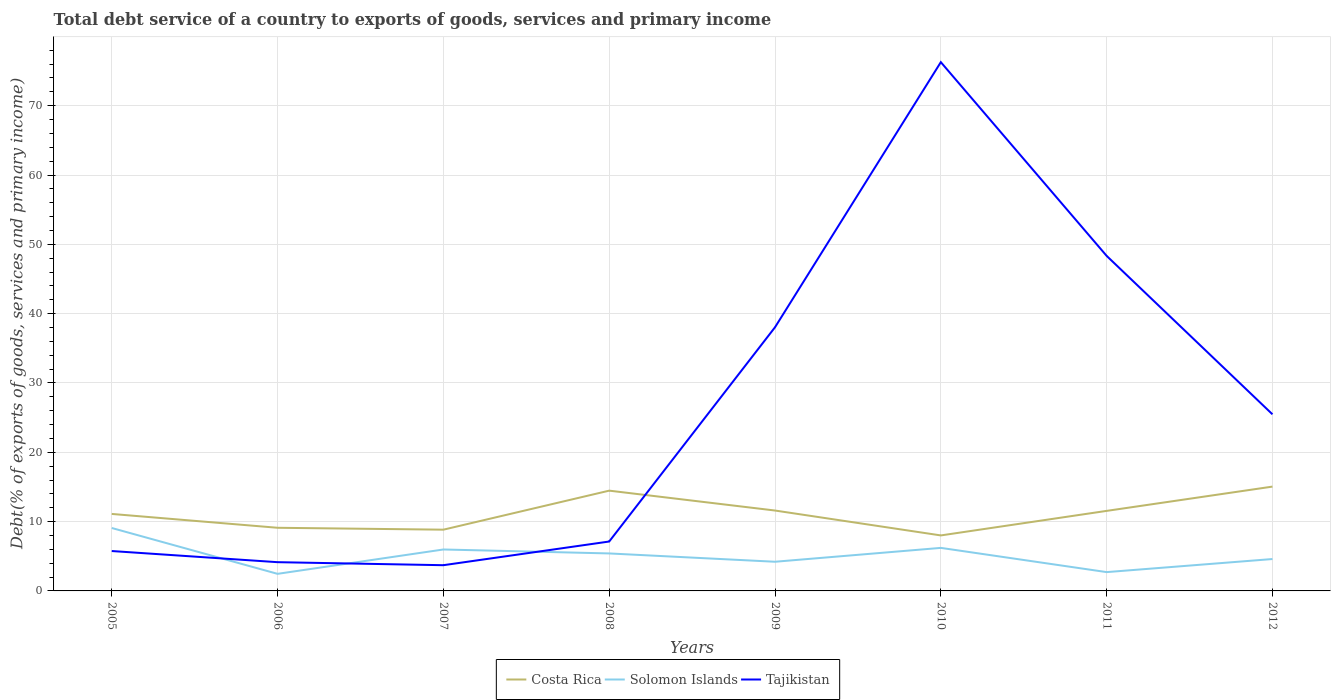How many different coloured lines are there?
Provide a short and direct response. 3. Does the line corresponding to Costa Rica intersect with the line corresponding to Solomon Islands?
Offer a terse response. No. Across all years, what is the maximum total debt service in Costa Rica?
Provide a succinct answer. 8.01. In which year was the total debt service in Solomon Islands maximum?
Your answer should be compact. 2006. What is the total total debt service in Costa Rica in the graph?
Offer a terse response. 2.87. What is the difference between the highest and the second highest total debt service in Solomon Islands?
Your answer should be very brief. 6.61. Are the values on the major ticks of Y-axis written in scientific E-notation?
Provide a short and direct response. No. Does the graph contain any zero values?
Provide a short and direct response. No. Does the graph contain grids?
Keep it short and to the point. Yes. Where does the legend appear in the graph?
Ensure brevity in your answer.  Bottom center. How many legend labels are there?
Provide a short and direct response. 3. What is the title of the graph?
Give a very brief answer. Total debt service of a country to exports of goods, services and primary income. Does "Antigua and Barbuda" appear as one of the legend labels in the graph?
Provide a short and direct response. No. What is the label or title of the X-axis?
Your answer should be compact. Years. What is the label or title of the Y-axis?
Your response must be concise. Debt(% of exports of goods, services and primary income). What is the Debt(% of exports of goods, services and primary income) in Costa Rica in 2005?
Give a very brief answer. 11.11. What is the Debt(% of exports of goods, services and primary income) in Solomon Islands in 2005?
Your answer should be very brief. 9.08. What is the Debt(% of exports of goods, services and primary income) in Tajikistan in 2005?
Your response must be concise. 5.75. What is the Debt(% of exports of goods, services and primary income) in Costa Rica in 2006?
Offer a very short reply. 9.11. What is the Debt(% of exports of goods, services and primary income) in Solomon Islands in 2006?
Offer a very short reply. 2.46. What is the Debt(% of exports of goods, services and primary income) of Tajikistan in 2006?
Make the answer very short. 4.15. What is the Debt(% of exports of goods, services and primary income) of Costa Rica in 2007?
Provide a short and direct response. 8.84. What is the Debt(% of exports of goods, services and primary income) of Solomon Islands in 2007?
Provide a short and direct response. 5.98. What is the Debt(% of exports of goods, services and primary income) in Tajikistan in 2007?
Provide a succinct answer. 3.71. What is the Debt(% of exports of goods, services and primary income) of Costa Rica in 2008?
Offer a very short reply. 14.46. What is the Debt(% of exports of goods, services and primary income) in Solomon Islands in 2008?
Keep it short and to the point. 5.41. What is the Debt(% of exports of goods, services and primary income) in Tajikistan in 2008?
Offer a very short reply. 7.13. What is the Debt(% of exports of goods, services and primary income) in Costa Rica in 2009?
Provide a succinct answer. 11.6. What is the Debt(% of exports of goods, services and primary income) in Solomon Islands in 2009?
Offer a very short reply. 4.21. What is the Debt(% of exports of goods, services and primary income) of Tajikistan in 2009?
Make the answer very short. 38.04. What is the Debt(% of exports of goods, services and primary income) of Costa Rica in 2010?
Make the answer very short. 8.01. What is the Debt(% of exports of goods, services and primary income) in Solomon Islands in 2010?
Your answer should be compact. 6.21. What is the Debt(% of exports of goods, services and primary income) in Tajikistan in 2010?
Offer a very short reply. 76.28. What is the Debt(% of exports of goods, services and primary income) of Costa Rica in 2011?
Your response must be concise. 11.55. What is the Debt(% of exports of goods, services and primary income) in Solomon Islands in 2011?
Your answer should be very brief. 2.71. What is the Debt(% of exports of goods, services and primary income) in Tajikistan in 2011?
Offer a terse response. 48.33. What is the Debt(% of exports of goods, services and primary income) of Costa Rica in 2012?
Make the answer very short. 15.05. What is the Debt(% of exports of goods, services and primary income) of Solomon Islands in 2012?
Offer a very short reply. 4.6. What is the Debt(% of exports of goods, services and primary income) in Tajikistan in 2012?
Keep it short and to the point. 25.48. Across all years, what is the maximum Debt(% of exports of goods, services and primary income) of Costa Rica?
Ensure brevity in your answer.  15.05. Across all years, what is the maximum Debt(% of exports of goods, services and primary income) in Solomon Islands?
Provide a short and direct response. 9.08. Across all years, what is the maximum Debt(% of exports of goods, services and primary income) of Tajikistan?
Give a very brief answer. 76.28. Across all years, what is the minimum Debt(% of exports of goods, services and primary income) of Costa Rica?
Your answer should be compact. 8.01. Across all years, what is the minimum Debt(% of exports of goods, services and primary income) in Solomon Islands?
Offer a terse response. 2.46. Across all years, what is the minimum Debt(% of exports of goods, services and primary income) in Tajikistan?
Provide a short and direct response. 3.71. What is the total Debt(% of exports of goods, services and primary income) of Costa Rica in the graph?
Provide a short and direct response. 89.72. What is the total Debt(% of exports of goods, services and primary income) in Solomon Islands in the graph?
Your answer should be compact. 40.66. What is the total Debt(% of exports of goods, services and primary income) of Tajikistan in the graph?
Keep it short and to the point. 208.86. What is the difference between the Debt(% of exports of goods, services and primary income) in Costa Rica in 2005 and that in 2006?
Offer a very short reply. 2. What is the difference between the Debt(% of exports of goods, services and primary income) of Solomon Islands in 2005 and that in 2006?
Provide a succinct answer. 6.61. What is the difference between the Debt(% of exports of goods, services and primary income) in Tajikistan in 2005 and that in 2006?
Offer a terse response. 1.61. What is the difference between the Debt(% of exports of goods, services and primary income) in Costa Rica in 2005 and that in 2007?
Your answer should be very brief. 2.27. What is the difference between the Debt(% of exports of goods, services and primary income) in Solomon Islands in 2005 and that in 2007?
Your answer should be very brief. 3.1. What is the difference between the Debt(% of exports of goods, services and primary income) in Tajikistan in 2005 and that in 2007?
Your answer should be very brief. 2.04. What is the difference between the Debt(% of exports of goods, services and primary income) in Costa Rica in 2005 and that in 2008?
Provide a succinct answer. -3.36. What is the difference between the Debt(% of exports of goods, services and primary income) of Solomon Islands in 2005 and that in 2008?
Offer a very short reply. 3.67. What is the difference between the Debt(% of exports of goods, services and primary income) in Tajikistan in 2005 and that in 2008?
Make the answer very short. -1.37. What is the difference between the Debt(% of exports of goods, services and primary income) of Costa Rica in 2005 and that in 2009?
Make the answer very short. -0.49. What is the difference between the Debt(% of exports of goods, services and primary income) of Solomon Islands in 2005 and that in 2009?
Your answer should be compact. 4.87. What is the difference between the Debt(% of exports of goods, services and primary income) in Tajikistan in 2005 and that in 2009?
Your answer should be very brief. -32.28. What is the difference between the Debt(% of exports of goods, services and primary income) of Costa Rica in 2005 and that in 2010?
Make the answer very short. 3.1. What is the difference between the Debt(% of exports of goods, services and primary income) in Solomon Islands in 2005 and that in 2010?
Provide a short and direct response. 2.87. What is the difference between the Debt(% of exports of goods, services and primary income) in Tajikistan in 2005 and that in 2010?
Your answer should be very brief. -70.52. What is the difference between the Debt(% of exports of goods, services and primary income) in Costa Rica in 2005 and that in 2011?
Give a very brief answer. -0.44. What is the difference between the Debt(% of exports of goods, services and primary income) in Solomon Islands in 2005 and that in 2011?
Keep it short and to the point. 6.36. What is the difference between the Debt(% of exports of goods, services and primary income) in Tajikistan in 2005 and that in 2011?
Provide a short and direct response. -42.58. What is the difference between the Debt(% of exports of goods, services and primary income) of Costa Rica in 2005 and that in 2012?
Offer a terse response. -3.94. What is the difference between the Debt(% of exports of goods, services and primary income) in Solomon Islands in 2005 and that in 2012?
Give a very brief answer. 4.48. What is the difference between the Debt(% of exports of goods, services and primary income) in Tajikistan in 2005 and that in 2012?
Give a very brief answer. -19.72. What is the difference between the Debt(% of exports of goods, services and primary income) of Costa Rica in 2006 and that in 2007?
Make the answer very short. 0.27. What is the difference between the Debt(% of exports of goods, services and primary income) of Solomon Islands in 2006 and that in 2007?
Give a very brief answer. -3.51. What is the difference between the Debt(% of exports of goods, services and primary income) of Tajikistan in 2006 and that in 2007?
Offer a terse response. 0.44. What is the difference between the Debt(% of exports of goods, services and primary income) in Costa Rica in 2006 and that in 2008?
Offer a very short reply. -5.35. What is the difference between the Debt(% of exports of goods, services and primary income) of Solomon Islands in 2006 and that in 2008?
Offer a terse response. -2.94. What is the difference between the Debt(% of exports of goods, services and primary income) in Tajikistan in 2006 and that in 2008?
Your answer should be compact. -2.98. What is the difference between the Debt(% of exports of goods, services and primary income) of Costa Rica in 2006 and that in 2009?
Offer a very short reply. -2.49. What is the difference between the Debt(% of exports of goods, services and primary income) of Solomon Islands in 2006 and that in 2009?
Ensure brevity in your answer.  -1.74. What is the difference between the Debt(% of exports of goods, services and primary income) of Tajikistan in 2006 and that in 2009?
Ensure brevity in your answer.  -33.89. What is the difference between the Debt(% of exports of goods, services and primary income) of Costa Rica in 2006 and that in 2010?
Give a very brief answer. 1.1. What is the difference between the Debt(% of exports of goods, services and primary income) of Solomon Islands in 2006 and that in 2010?
Provide a short and direct response. -3.74. What is the difference between the Debt(% of exports of goods, services and primary income) in Tajikistan in 2006 and that in 2010?
Provide a short and direct response. -72.13. What is the difference between the Debt(% of exports of goods, services and primary income) of Costa Rica in 2006 and that in 2011?
Your answer should be compact. -2.44. What is the difference between the Debt(% of exports of goods, services and primary income) in Solomon Islands in 2006 and that in 2011?
Give a very brief answer. -0.25. What is the difference between the Debt(% of exports of goods, services and primary income) in Tajikistan in 2006 and that in 2011?
Your answer should be compact. -44.19. What is the difference between the Debt(% of exports of goods, services and primary income) of Costa Rica in 2006 and that in 2012?
Your response must be concise. -5.94. What is the difference between the Debt(% of exports of goods, services and primary income) in Solomon Islands in 2006 and that in 2012?
Your answer should be compact. -2.14. What is the difference between the Debt(% of exports of goods, services and primary income) in Tajikistan in 2006 and that in 2012?
Ensure brevity in your answer.  -21.33. What is the difference between the Debt(% of exports of goods, services and primary income) in Costa Rica in 2007 and that in 2008?
Offer a very short reply. -5.63. What is the difference between the Debt(% of exports of goods, services and primary income) in Solomon Islands in 2007 and that in 2008?
Your response must be concise. 0.57. What is the difference between the Debt(% of exports of goods, services and primary income) of Tajikistan in 2007 and that in 2008?
Your answer should be compact. -3.42. What is the difference between the Debt(% of exports of goods, services and primary income) of Costa Rica in 2007 and that in 2009?
Offer a terse response. -2.76. What is the difference between the Debt(% of exports of goods, services and primary income) in Solomon Islands in 2007 and that in 2009?
Make the answer very short. 1.77. What is the difference between the Debt(% of exports of goods, services and primary income) of Tajikistan in 2007 and that in 2009?
Your answer should be compact. -34.33. What is the difference between the Debt(% of exports of goods, services and primary income) of Costa Rica in 2007 and that in 2010?
Give a very brief answer. 0.83. What is the difference between the Debt(% of exports of goods, services and primary income) of Solomon Islands in 2007 and that in 2010?
Your answer should be very brief. -0.23. What is the difference between the Debt(% of exports of goods, services and primary income) of Tajikistan in 2007 and that in 2010?
Ensure brevity in your answer.  -72.57. What is the difference between the Debt(% of exports of goods, services and primary income) in Costa Rica in 2007 and that in 2011?
Your answer should be very brief. -2.71. What is the difference between the Debt(% of exports of goods, services and primary income) in Solomon Islands in 2007 and that in 2011?
Your response must be concise. 3.26. What is the difference between the Debt(% of exports of goods, services and primary income) of Tajikistan in 2007 and that in 2011?
Your response must be concise. -44.62. What is the difference between the Debt(% of exports of goods, services and primary income) in Costa Rica in 2007 and that in 2012?
Make the answer very short. -6.21. What is the difference between the Debt(% of exports of goods, services and primary income) of Solomon Islands in 2007 and that in 2012?
Keep it short and to the point. 1.38. What is the difference between the Debt(% of exports of goods, services and primary income) in Tajikistan in 2007 and that in 2012?
Offer a very short reply. -21.77. What is the difference between the Debt(% of exports of goods, services and primary income) of Costa Rica in 2008 and that in 2009?
Offer a terse response. 2.87. What is the difference between the Debt(% of exports of goods, services and primary income) in Solomon Islands in 2008 and that in 2009?
Your response must be concise. 1.2. What is the difference between the Debt(% of exports of goods, services and primary income) of Tajikistan in 2008 and that in 2009?
Ensure brevity in your answer.  -30.91. What is the difference between the Debt(% of exports of goods, services and primary income) in Costa Rica in 2008 and that in 2010?
Provide a succinct answer. 6.46. What is the difference between the Debt(% of exports of goods, services and primary income) of Solomon Islands in 2008 and that in 2010?
Your response must be concise. -0.8. What is the difference between the Debt(% of exports of goods, services and primary income) in Tajikistan in 2008 and that in 2010?
Your answer should be compact. -69.15. What is the difference between the Debt(% of exports of goods, services and primary income) in Costa Rica in 2008 and that in 2011?
Your answer should be very brief. 2.92. What is the difference between the Debt(% of exports of goods, services and primary income) in Solomon Islands in 2008 and that in 2011?
Your answer should be compact. 2.69. What is the difference between the Debt(% of exports of goods, services and primary income) of Tajikistan in 2008 and that in 2011?
Your answer should be very brief. -41.2. What is the difference between the Debt(% of exports of goods, services and primary income) of Costa Rica in 2008 and that in 2012?
Make the answer very short. -0.58. What is the difference between the Debt(% of exports of goods, services and primary income) of Solomon Islands in 2008 and that in 2012?
Offer a very short reply. 0.81. What is the difference between the Debt(% of exports of goods, services and primary income) of Tajikistan in 2008 and that in 2012?
Give a very brief answer. -18.35. What is the difference between the Debt(% of exports of goods, services and primary income) in Costa Rica in 2009 and that in 2010?
Offer a very short reply. 3.59. What is the difference between the Debt(% of exports of goods, services and primary income) in Solomon Islands in 2009 and that in 2010?
Offer a terse response. -2. What is the difference between the Debt(% of exports of goods, services and primary income) of Tajikistan in 2009 and that in 2010?
Make the answer very short. -38.24. What is the difference between the Debt(% of exports of goods, services and primary income) of Costa Rica in 2009 and that in 2011?
Keep it short and to the point. 0.05. What is the difference between the Debt(% of exports of goods, services and primary income) of Solomon Islands in 2009 and that in 2011?
Provide a succinct answer. 1.49. What is the difference between the Debt(% of exports of goods, services and primary income) in Tajikistan in 2009 and that in 2011?
Your answer should be compact. -10.3. What is the difference between the Debt(% of exports of goods, services and primary income) of Costa Rica in 2009 and that in 2012?
Provide a short and direct response. -3.45. What is the difference between the Debt(% of exports of goods, services and primary income) of Solomon Islands in 2009 and that in 2012?
Give a very brief answer. -0.39. What is the difference between the Debt(% of exports of goods, services and primary income) in Tajikistan in 2009 and that in 2012?
Keep it short and to the point. 12.56. What is the difference between the Debt(% of exports of goods, services and primary income) of Costa Rica in 2010 and that in 2011?
Your answer should be compact. -3.54. What is the difference between the Debt(% of exports of goods, services and primary income) in Solomon Islands in 2010 and that in 2011?
Offer a terse response. 3.49. What is the difference between the Debt(% of exports of goods, services and primary income) in Tajikistan in 2010 and that in 2011?
Offer a very short reply. 27.95. What is the difference between the Debt(% of exports of goods, services and primary income) in Costa Rica in 2010 and that in 2012?
Your answer should be compact. -7.04. What is the difference between the Debt(% of exports of goods, services and primary income) of Solomon Islands in 2010 and that in 2012?
Make the answer very short. 1.61. What is the difference between the Debt(% of exports of goods, services and primary income) of Tajikistan in 2010 and that in 2012?
Give a very brief answer. 50.8. What is the difference between the Debt(% of exports of goods, services and primary income) in Costa Rica in 2011 and that in 2012?
Give a very brief answer. -3.5. What is the difference between the Debt(% of exports of goods, services and primary income) in Solomon Islands in 2011 and that in 2012?
Keep it short and to the point. -1.89. What is the difference between the Debt(% of exports of goods, services and primary income) of Tajikistan in 2011 and that in 2012?
Provide a short and direct response. 22.85. What is the difference between the Debt(% of exports of goods, services and primary income) in Costa Rica in 2005 and the Debt(% of exports of goods, services and primary income) in Solomon Islands in 2006?
Your answer should be very brief. 8.64. What is the difference between the Debt(% of exports of goods, services and primary income) of Costa Rica in 2005 and the Debt(% of exports of goods, services and primary income) of Tajikistan in 2006?
Keep it short and to the point. 6.96. What is the difference between the Debt(% of exports of goods, services and primary income) in Solomon Islands in 2005 and the Debt(% of exports of goods, services and primary income) in Tajikistan in 2006?
Provide a short and direct response. 4.93. What is the difference between the Debt(% of exports of goods, services and primary income) of Costa Rica in 2005 and the Debt(% of exports of goods, services and primary income) of Solomon Islands in 2007?
Ensure brevity in your answer.  5.13. What is the difference between the Debt(% of exports of goods, services and primary income) of Costa Rica in 2005 and the Debt(% of exports of goods, services and primary income) of Tajikistan in 2007?
Keep it short and to the point. 7.39. What is the difference between the Debt(% of exports of goods, services and primary income) of Solomon Islands in 2005 and the Debt(% of exports of goods, services and primary income) of Tajikistan in 2007?
Keep it short and to the point. 5.37. What is the difference between the Debt(% of exports of goods, services and primary income) of Costa Rica in 2005 and the Debt(% of exports of goods, services and primary income) of Solomon Islands in 2008?
Offer a terse response. 5.7. What is the difference between the Debt(% of exports of goods, services and primary income) in Costa Rica in 2005 and the Debt(% of exports of goods, services and primary income) in Tajikistan in 2008?
Ensure brevity in your answer.  3.98. What is the difference between the Debt(% of exports of goods, services and primary income) of Solomon Islands in 2005 and the Debt(% of exports of goods, services and primary income) of Tajikistan in 2008?
Give a very brief answer. 1.95. What is the difference between the Debt(% of exports of goods, services and primary income) of Costa Rica in 2005 and the Debt(% of exports of goods, services and primary income) of Solomon Islands in 2009?
Provide a succinct answer. 6.9. What is the difference between the Debt(% of exports of goods, services and primary income) of Costa Rica in 2005 and the Debt(% of exports of goods, services and primary income) of Tajikistan in 2009?
Your response must be concise. -26.93. What is the difference between the Debt(% of exports of goods, services and primary income) in Solomon Islands in 2005 and the Debt(% of exports of goods, services and primary income) in Tajikistan in 2009?
Offer a very short reply. -28.96. What is the difference between the Debt(% of exports of goods, services and primary income) in Costa Rica in 2005 and the Debt(% of exports of goods, services and primary income) in Solomon Islands in 2010?
Your answer should be very brief. 4.9. What is the difference between the Debt(% of exports of goods, services and primary income) of Costa Rica in 2005 and the Debt(% of exports of goods, services and primary income) of Tajikistan in 2010?
Ensure brevity in your answer.  -65.17. What is the difference between the Debt(% of exports of goods, services and primary income) in Solomon Islands in 2005 and the Debt(% of exports of goods, services and primary income) in Tajikistan in 2010?
Your answer should be compact. -67.2. What is the difference between the Debt(% of exports of goods, services and primary income) of Costa Rica in 2005 and the Debt(% of exports of goods, services and primary income) of Solomon Islands in 2011?
Ensure brevity in your answer.  8.39. What is the difference between the Debt(% of exports of goods, services and primary income) of Costa Rica in 2005 and the Debt(% of exports of goods, services and primary income) of Tajikistan in 2011?
Keep it short and to the point. -37.23. What is the difference between the Debt(% of exports of goods, services and primary income) in Solomon Islands in 2005 and the Debt(% of exports of goods, services and primary income) in Tajikistan in 2011?
Make the answer very short. -39.25. What is the difference between the Debt(% of exports of goods, services and primary income) in Costa Rica in 2005 and the Debt(% of exports of goods, services and primary income) in Solomon Islands in 2012?
Your answer should be compact. 6.51. What is the difference between the Debt(% of exports of goods, services and primary income) of Costa Rica in 2005 and the Debt(% of exports of goods, services and primary income) of Tajikistan in 2012?
Your answer should be compact. -14.37. What is the difference between the Debt(% of exports of goods, services and primary income) of Solomon Islands in 2005 and the Debt(% of exports of goods, services and primary income) of Tajikistan in 2012?
Offer a very short reply. -16.4. What is the difference between the Debt(% of exports of goods, services and primary income) of Costa Rica in 2006 and the Debt(% of exports of goods, services and primary income) of Solomon Islands in 2007?
Ensure brevity in your answer.  3.13. What is the difference between the Debt(% of exports of goods, services and primary income) in Costa Rica in 2006 and the Debt(% of exports of goods, services and primary income) in Tajikistan in 2007?
Offer a terse response. 5.4. What is the difference between the Debt(% of exports of goods, services and primary income) of Solomon Islands in 2006 and the Debt(% of exports of goods, services and primary income) of Tajikistan in 2007?
Offer a terse response. -1.25. What is the difference between the Debt(% of exports of goods, services and primary income) in Costa Rica in 2006 and the Debt(% of exports of goods, services and primary income) in Solomon Islands in 2008?
Offer a very short reply. 3.7. What is the difference between the Debt(% of exports of goods, services and primary income) of Costa Rica in 2006 and the Debt(% of exports of goods, services and primary income) of Tajikistan in 2008?
Ensure brevity in your answer.  1.98. What is the difference between the Debt(% of exports of goods, services and primary income) in Solomon Islands in 2006 and the Debt(% of exports of goods, services and primary income) in Tajikistan in 2008?
Offer a very short reply. -4.66. What is the difference between the Debt(% of exports of goods, services and primary income) in Costa Rica in 2006 and the Debt(% of exports of goods, services and primary income) in Solomon Islands in 2009?
Ensure brevity in your answer.  4.9. What is the difference between the Debt(% of exports of goods, services and primary income) in Costa Rica in 2006 and the Debt(% of exports of goods, services and primary income) in Tajikistan in 2009?
Your answer should be very brief. -28.93. What is the difference between the Debt(% of exports of goods, services and primary income) in Solomon Islands in 2006 and the Debt(% of exports of goods, services and primary income) in Tajikistan in 2009?
Keep it short and to the point. -35.57. What is the difference between the Debt(% of exports of goods, services and primary income) of Costa Rica in 2006 and the Debt(% of exports of goods, services and primary income) of Solomon Islands in 2010?
Offer a terse response. 2.9. What is the difference between the Debt(% of exports of goods, services and primary income) of Costa Rica in 2006 and the Debt(% of exports of goods, services and primary income) of Tajikistan in 2010?
Offer a very short reply. -67.17. What is the difference between the Debt(% of exports of goods, services and primary income) of Solomon Islands in 2006 and the Debt(% of exports of goods, services and primary income) of Tajikistan in 2010?
Your answer should be compact. -73.81. What is the difference between the Debt(% of exports of goods, services and primary income) of Costa Rica in 2006 and the Debt(% of exports of goods, services and primary income) of Solomon Islands in 2011?
Your answer should be compact. 6.4. What is the difference between the Debt(% of exports of goods, services and primary income) in Costa Rica in 2006 and the Debt(% of exports of goods, services and primary income) in Tajikistan in 2011?
Provide a short and direct response. -39.22. What is the difference between the Debt(% of exports of goods, services and primary income) in Solomon Islands in 2006 and the Debt(% of exports of goods, services and primary income) in Tajikistan in 2011?
Keep it short and to the point. -45.87. What is the difference between the Debt(% of exports of goods, services and primary income) in Costa Rica in 2006 and the Debt(% of exports of goods, services and primary income) in Solomon Islands in 2012?
Keep it short and to the point. 4.51. What is the difference between the Debt(% of exports of goods, services and primary income) in Costa Rica in 2006 and the Debt(% of exports of goods, services and primary income) in Tajikistan in 2012?
Your answer should be very brief. -16.37. What is the difference between the Debt(% of exports of goods, services and primary income) of Solomon Islands in 2006 and the Debt(% of exports of goods, services and primary income) of Tajikistan in 2012?
Provide a succinct answer. -23.01. What is the difference between the Debt(% of exports of goods, services and primary income) of Costa Rica in 2007 and the Debt(% of exports of goods, services and primary income) of Solomon Islands in 2008?
Make the answer very short. 3.43. What is the difference between the Debt(% of exports of goods, services and primary income) in Costa Rica in 2007 and the Debt(% of exports of goods, services and primary income) in Tajikistan in 2008?
Keep it short and to the point. 1.71. What is the difference between the Debt(% of exports of goods, services and primary income) of Solomon Islands in 2007 and the Debt(% of exports of goods, services and primary income) of Tajikistan in 2008?
Keep it short and to the point. -1.15. What is the difference between the Debt(% of exports of goods, services and primary income) in Costa Rica in 2007 and the Debt(% of exports of goods, services and primary income) in Solomon Islands in 2009?
Offer a very short reply. 4.63. What is the difference between the Debt(% of exports of goods, services and primary income) of Costa Rica in 2007 and the Debt(% of exports of goods, services and primary income) of Tajikistan in 2009?
Give a very brief answer. -29.2. What is the difference between the Debt(% of exports of goods, services and primary income) of Solomon Islands in 2007 and the Debt(% of exports of goods, services and primary income) of Tajikistan in 2009?
Provide a short and direct response. -32.06. What is the difference between the Debt(% of exports of goods, services and primary income) of Costa Rica in 2007 and the Debt(% of exports of goods, services and primary income) of Solomon Islands in 2010?
Offer a very short reply. 2.63. What is the difference between the Debt(% of exports of goods, services and primary income) of Costa Rica in 2007 and the Debt(% of exports of goods, services and primary income) of Tajikistan in 2010?
Ensure brevity in your answer.  -67.44. What is the difference between the Debt(% of exports of goods, services and primary income) in Solomon Islands in 2007 and the Debt(% of exports of goods, services and primary income) in Tajikistan in 2010?
Offer a terse response. -70.3. What is the difference between the Debt(% of exports of goods, services and primary income) in Costa Rica in 2007 and the Debt(% of exports of goods, services and primary income) in Solomon Islands in 2011?
Provide a succinct answer. 6.12. What is the difference between the Debt(% of exports of goods, services and primary income) of Costa Rica in 2007 and the Debt(% of exports of goods, services and primary income) of Tajikistan in 2011?
Make the answer very short. -39.5. What is the difference between the Debt(% of exports of goods, services and primary income) in Solomon Islands in 2007 and the Debt(% of exports of goods, services and primary income) in Tajikistan in 2011?
Make the answer very short. -42.35. What is the difference between the Debt(% of exports of goods, services and primary income) of Costa Rica in 2007 and the Debt(% of exports of goods, services and primary income) of Solomon Islands in 2012?
Your response must be concise. 4.24. What is the difference between the Debt(% of exports of goods, services and primary income) in Costa Rica in 2007 and the Debt(% of exports of goods, services and primary income) in Tajikistan in 2012?
Ensure brevity in your answer.  -16.64. What is the difference between the Debt(% of exports of goods, services and primary income) of Solomon Islands in 2007 and the Debt(% of exports of goods, services and primary income) of Tajikistan in 2012?
Provide a short and direct response. -19.5. What is the difference between the Debt(% of exports of goods, services and primary income) in Costa Rica in 2008 and the Debt(% of exports of goods, services and primary income) in Solomon Islands in 2009?
Provide a succinct answer. 10.26. What is the difference between the Debt(% of exports of goods, services and primary income) of Costa Rica in 2008 and the Debt(% of exports of goods, services and primary income) of Tajikistan in 2009?
Your answer should be very brief. -23.57. What is the difference between the Debt(% of exports of goods, services and primary income) in Solomon Islands in 2008 and the Debt(% of exports of goods, services and primary income) in Tajikistan in 2009?
Provide a succinct answer. -32.63. What is the difference between the Debt(% of exports of goods, services and primary income) of Costa Rica in 2008 and the Debt(% of exports of goods, services and primary income) of Solomon Islands in 2010?
Your answer should be compact. 8.26. What is the difference between the Debt(% of exports of goods, services and primary income) in Costa Rica in 2008 and the Debt(% of exports of goods, services and primary income) in Tajikistan in 2010?
Offer a terse response. -61.81. What is the difference between the Debt(% of exports of goods, services and primary income) in Solomon Islands in 2008 and the Debt(% of exports of goods, services and primary income) in Tajikistan in 2010?
Give a very brief answer. -70.87. What is the difference between the Debt(% of exports of goods, services and primary income) in Costa Rica in 2008 and the Debt(% of exports of goods, services and primary income) in Solomon Islands in 2011?
Your answer should be very brief. 11.75. What is the difference between the Debt(% of exports of goods, services and primary income) of Costa Rica in 2008 and the Debt(% of exports of goods, services and primary income) of Tajikistan in 2011?
Offer a very short reply. -33.87. What is the difference between the Debt(% of exports of goods, services and primary income) of Solomon Islands in 2008 and the Debt(% of exports of goods, services and primary income) of Tajikistan in 2011?
Keep it short and to the point. -42.92. What is the difference between the Debt(% of exports of goods, services and primary income) of Costa Rica in 2008 and the Debt(% of exports of goods, services and primary income) of Solomon Islands in 2012?
Offer a very short reply. 9.86. What is the difference between the Debt(% of exports of goods, services and primary income) of Costa Rica in 2008 and the Debt(% of exports of goods, services and primary income) of Tajikistan in 2012?
Offer a terse response. -11.01. What is the difference between the Debt(% of exports of goods, services and primary income) of Solomon Islands in 2008 and the Debt(% of exports of goods, services and primary income) of Tajikistan in 2012?
Your answer should be very brief. -20.07. What is the difference between the Debt(% of exports of goods, services and primary income) in Costa Rica in 2009 and the Debt(% of exports of goods, services and primary income) in Solomon Islands in 2010?
Your answer should be compact. 5.39. What is the difference between the Debt(% of exports of goods, services and primary income) in Costa Rica in 2009 and the Debt(% of exports of goods, services and primary income) in Tajikistan in 2010?
Offer a very short reply. -64.68. What is the difference between the Debt(% of exports of goods, services and primary income) in Solomon Islands in 2009 and the Debt(% of exports of goods, services and primary income) in Tajikistan in 2010?
Ensure brevity in your answer.  -72.07. What is the difference between the Debt(% of exports of goods, services and primary income) of Costa Rica in 2009 and the Debt(% of exports of goods, services and primary income) of Solomon Islands in 2011?
Ensure brevity in your answer.  8.88. What is the difference between the Debt(% of exports of goods, services and primary income) in Costa Rica in 2009 and the Debt(% of exports of goods, services and primary income) in Tajikistan in 2011?
Give a very brief answer. -36.73. What is the difference between the Debt(% of exports of goods, services and primary income) in Solomon Islands in 2009 and the Debt(% of exports of goods, services and primary income) in Tajikistan in 2011?
Ensure brevity in your answer.  -44.12. What is the difference between the Debt(% of exports of goods, services and primary income) of Costa Rica in 2009 and the Debt(% of exports of goods, services and primary income) of Solomon Islands in 2012?
Give a very brief answer. 7. What is the difference between the Debt(% of exports of goods, services and primary income) of Costa Rica in 2009 and the Debt(% of exports of goods, services and primary income) of Tajikistan in 2012?
Give a very brief answer. -13.88. What is the difference between the Debt(% of exports of goods, services and primary income) of Solomon Islands in 2009 and the Debt(% of exports of goods, services and primary income) of Tajikistan in 2012?
Offer a very short reply. -21.27. What is the difference between the Debt(% of exports of goods, services and primary income) of Costa Rica in 2010 and the Debt(% of exports of goods, services and primary income) of Solomon Islands in 2011?
Your answer should be very brief. 5.29. What is the difference between the Debt(% of exports of goods, services and primary income) of Costa Rica in 2010 and the Debt(% of exports of goods, services and primary income) of Tajikistan in 2011?
Keep it short and to the point. -40.33. What is the difference between the Debt(% of exports of goods, services and primary income) of Solomon Islands in 2010 and the Debt(% of exports of goods, services and primary income) of Tajikistan in 2011?
Give a very brief answer. -42.12. What is the difference between the Debt(% of exports of goods, services and primary income) of Costa Rica in 2010 and the Debt(% of exports of goods, services and primary income) of Solomon Islands in 2012?
Make the answer very short. 3.41. What is the difference between the Debt(% of exports of goods, services and primary income) in Costa Rica in 2010 and the Debt(% of exports of goods, services and primary income) in Tajikistan in 2012?
Your response must be concise. -17.47. What is the difference between the Debt(% of exports of goods, services and primary income) of Solomon Islands in 2010 and the Debt(% of exports of goods, services and primary income) of Tajikistan in 2012?
Give a very brief answer. -19.27. What is the difference between the Debt(% of exports of goods, services and primary income) of Costa Rica in 2011 and the Debt(% of exports of goods, services and primary income) of Solomon Islands in 2012?
Your answer should be very brief. 6.95. What is the difference between the Debt(% of exports of goods, services and primary income) of Costa Rica in 2011 and the Debt(% of exports of goods, services and primary income) of Tajikistan in 2012?
Your answer should be compact. -13.93. What is the difference between the Debt(% of exports of goods, services and primary income) in Solomon Islands in 2011 and the Debt(% of exports of goods, services and primary income) in Tajikistan in 2012?
Offer a very short reply. -22.76. What is the average Debt(% of exports of goods, services and primary income) of Costa Rica per year?
Make the answer very short. 11.21. What is the average Debt(% of exports of goods, services and primary income) in Solomon Islands per year?
Offer a very short reply. 5.08. What is the average Debt(% of exports of goods, services and primary income) of Tajikistan per year?
Your response must be concise. 26.11. In the year 2005, what is the difference between the Debt(% of exports of goods, services and primary income) of Costa Rica and Debt(% of exports of goods, services and primary income) of Solomon Islands?
Offer a very short reply. 2.03. In the year 2005, what is the difference between the Debt(% of exports of goods, services and primary income) in Costa Rica and Debt(% of exports of goods, services and primary income) in Tajikistan?
Ensure brevity in your answer.  5.35. In the year 2005, what is the difference between the Debt(% of exports of goods, services and primary income) in Solomon Islands and Debt(% of exports of goods, services and primary income) in Tajikistan?
Give a very brief answer. 3.32. In the year 2006, what is the difference between the Debt(% of exports of goods, services and primary income) in Costa Rica and Debt(% of exports of goods, services and primary income) in Solomon Islands?
Provide a short and direct response. 6.65. In the year 2006, what is the difference between the Debt(% of exports of goods, services and primary income) of Costa Rica and Debt(% of exports of goods, services and primary income) of Tajikistan?
Your response must be concise. 4.96. In the year 2006, what is the difference between the Debt(% of exports of goods, services and primary income) in Solomon Islands and Debt(% of exports of goods, services and primary income) in Tajikistan?
Your response must be concise. -1.68. In the year 2007, what is the difference between the Debt(% of exports of goods, services and primary income) of Costa Rica and Debt(% of exports of goods, services and primary income) of Solomon Islands?
Offer a terse response. 2.86. In the year 2007, what is the difference between the Debt(% of exports of goods, services and primary income) of Costa Rica and Debt(% of exports of goods, services and primary income) of Tajikistan?
Your response must be concise. 5.13. In the year 2007, what is the difference between the Debt(% of exports of goods, services and primary income) of Solomon Islands and Debt(% of exports of goods, services and primary income) of Tajikistan?
Ensure brevity in your answer.  2.27. In the year 2008, what is the difference between the Debt(% of exports of goods, services and primary income) in Costa Rica and Debt(% of exports of goods, services and primary income) in Solomon Islands?
Your answer should be very brief. 9.06. In the year 2008, what is the difference between the Debt(% of exports of goods, services and primary income) of Costa Rica and Debt(% of exports of goods, services and primary income) of Tajikistan?
Ensure brevity in your answer.  7.34. In the year 2008, what is the difference between the Debt(% of exports of goods, services and primary income) in Solomon Islands and Debt(% of exports of goods, services and primary income) in Tajikistan?
Ensure brevity in your answer.  -1.72. In the year 2009, what is the difference between the Debt(% of exports of goods, services and primary income) in Costa Rica and Debt(% of exports of goods, services and primary income) in Solomon Islands?
Your answer should be compact. 7.39. In the year 2009, what is the difference between the Debt(% of exports of goods, services and primary income) of Costa Rica and Debt(% of exports of goods, services and primary income) of Tajikistan?
Offer a terse response. -26.44. In the year 2009, what is the difference between the Debt(% of exports of goods, services and primary income) in Solomon Islands and Debt(% of exports of goods, services and primary income) in Tajikistan?
Provide a short and direct response. -33.83. In the year 2010, what is the difference between the Debt(% of exports of goods, services and primary income) in Costa Rica and Debt(% of exports of goods, services and primary income) in Solomon Islands?
Offer a terse response. 1.8. In the year 2010, what is the difference between the Debt(% of exports of goods, services and primary income) in Costa Rica and Debt(% of exports of goods, services and primary income) in Tajikistan?
Your answer should be compact. -68.27. In the year 2010, what is the difference between the Debt(% of exports of goods, services and primary income) of Solomon Islands and Debt(% of exports of goods, services and primary income) of Tajikistan?
Your answer should be very brief. -70.07. In the year 2011, what is the difference between the Debt(% of exports of goods, services and primary income) in Costa Rica and Debt(% of exports of goods, services and primary income) in Solomon Islands?
Your response must be concise. 8.83. In the year 2011, what is the difference between the Debt(% of exports of goods, services and primary income) of Costa Rica and Debt(% of exports of goods, services and primary income) of Tajikistan?
Provide a succinct answer. -36.79. In the year 2011, what is the difference between the Debt(% of exports of goods, services and primary income) in Solomon Islands and Debt(% of exports of goods, services and primary income) in Tajikistan?
Provide a short and direct response. -45.62. In the year 2012, what is the difference between the Debt(% of exports of goods, services and primary income) of Costa Rica and Debt(% of exports of goods, services and primary income) of Solomon Islands?
Give a very brief answer. 10.45. In the year 2012, what is the difference between the Debt(% of exports of goods, services and primary income) in Costa Rica and Debt(% of exports of goods, services and primary income) in Tajikistan?
Give a very brief answer. -10.43. In the year 2012, what is the difference between the Debt(% of exports of goods, services and primary income) of Solomon Islands and Debt(% of exports of goods, services and primary income) of Tajikistan?
Your response must be concise. -20.88. What is the ratio of the Debt(% of exports of goods, services and primary income) of Costa Rica in 2005 to that in 2006?
Offer a very short reply. 1.22. What is the ratio of the Debt(% of exports of goods, services and primary income) in Solomon Islands in 2005 to that in 2006?
Your response must be concise. 3.68. What is the ratio of the Debt(% of exports of goods, services and primary income) of Tajikistan in 2005 to that in 2006?
Your answer should be very brief. 1.39. What is the ratio of the Debt(% of exports of goods, services and primary income) of Costa Rica in 2005 to that in 2007?
Your answer should be very brief. 1.26. What is the ratio of the Debt(% of exports of goods, services and primary income) in Solomon Islands in 2005 to that in 2007?
Keep it short and to the point. 1.52. What is the ratio of the Debt(% of exports of goods, services and primary income) of Tajikistan in 2005 to that in 2007?
Make the answer very short. 1.55. What is the ratio of the Debt(% of exports of goods, services and primary income) in Costa Rica in 2005 to that in 2008?
Offer a very short reply. 0.77. What is the ratio of the Debt(% of exports of goods, services and primary income) of Solomon Islands in 2005 to that in 2008?
Offer a terse response. 1.68. What is the ratio of the Debt(% of exports of goods, services and primary income) in Tajikistan in 2005 to that in 2008?
Your answer should be compact. 0.81. What is the ratio of the Debt(% of exports of goods, services and primary income) of Costa Rica in 2005 to that in 2009?
Offer a terse response. 0.96. What is the ratio of the Debt(% of exports of goods, services and primary income) in Solomon Islands in 2005 to that in 2009?
Offer a terse response. 2.16. What is the ratio of the Debt(% of exports of goods, services and primary income) of Tajikistan in 2005 to that in 2009?
Offer a very short reply. 0.15. What is the ratio of the Debt(% of exports of goods, services and primary income) of Costa Rica in 2005 to that in 2010?
Your answer should be compact. 1.39. What is the ratio of the Debt(% of exports of goods, services and primary income) in Solomon Islands in 2005 to that in 2010?
Your response must be concise. 1.46. What is the ratio of the Debt(% of exports of goods, services and primary income) of Tajikistan in 2005 to that in 2010?
Offer a very short reply. 0.08. What is the ratio of the Debt(% of exports of goods, services and primary income) of Costa Rica in 2005 to that in 2011?
Make the answer very short. 0.96. What is the ratio of the Debt(% of exports of goods, services and primary income) of Solomon Islands in 2005 to that in 2011?
Make the answer very short. 3.35. What is the ratio of the Debt(% of exports of goods, services and primary income) in Tajikistan in 2005 to that in 2011?
Your response must be concise. 0.12. What is the ratio of the Debt(% of exports of goods, services and primary income) of Costa Rica in 2005 to that in 2012?
Your answer should be compact. 0.74. What is the ratio of the Debt(% of exports of goods, services and primary income) of Solomon Islands in 2005 to that in 2012?
Keep it short and to the point. 1.97. What is the ratio of the Debt(% of exports of goods, services and primary income) in Tajikistan in 2005 to that in 2012?
Provide a succinct answer. 0.23. What is the ratio of the Debt(% of exports of goods, services and primary income) of Costa Rica in 2006 to that in 2007?
Your answer should be very brief. 1.03. What is the ratio of the Debt(% of exports of goods, services and primary income) of Solomon Islands in 2006 to that in 2007?
Make the answer very short. 0.41. What is the ratio of the Debt(% of exports of goods, services and primary income) in Tajikistan in 2006 to that in 2007?
Give a very brief answer. 1.12. What is the ratio of the Debt(% of exports of goods, services and primary income) in Costa Rica in 2006 to that in 2008?
Offer a terse response. 0.63. What is the ratio of the Debt(% of exports of goods, services and primary income) of Solomon Islands in 2006 to that in 2008?
Your response must be concise. 0.46. What is the ratio of the Debt(% of exports of goods, services and primary income) in Tajikistan in 2006 to that in 2008?
Make the answer very short. 0.58. What is the ratio of the Debt(% of exports of goods, services and primary income) in Costa Rica in 2006 to that in 2009?
Give a very brief answer. 0.79. What is the ratio of the Debt(% of exports of goods, services and primary income) in Solomon Islands in 2006 to that in 2009?
Your response must be concise. 0.59. What is the ratio of the Debt(% of exports of goods, services and primary income) in Tajikistan in 2006 to that in 2009?
Make the answer very short. 0.11. What is the ratio of the Debt(% of exports of goods, services and primary income) of Costa Rica in 2006 to that in 2010?
Make the answer very short. 1.14. What is the ratio of the Debt(% of exports of goods, services and primary income) of Solomon Islands in 2006 to that in 2010?
Give a very brief answer. 0.4. What is the ratio of the Debt(% of exports of goods, services and primary income) of Tajikistan in 2006 to that in 2010?
Offer a very short reply. 0.05. What is the ratio of the Debt(% of exports of goods, services and primary income) of Costa Rica in 2006 to that in 2011?
Ensure brevity in your answer.  0.79. What is the ratio of the Debt(% of exports of goods, services and primary income) in Solomon Islands in 2006 to that in 2011?
Provide a succinct answer. 0.91. What is the ratio of the Debt(% of exports of goods, services and primary income) of Tajikistan in 2006 to that in 2011?
Give a very brief answer. 0.09. What is the ratio of the Debt(% of exports of goods, services and primary income) of Costa Rica in 2006 to that in 2012?
Offer a terse response. 0.61. What is the ratio of the Debt(% of exports of goods, services and primary income) in Solomon Islands in 2006 to that in 2012?
Offer a very short reply. 0.54. What is the ratio of the Debt(% of exports of goods, services and primary income) in Tajikistan in 2006 to that in 2012?
Offer a very short reply. 0.16. What is the ratio of the Debt(% of exports of goods, services and primary income) of Costa Rica in 2007 to that in 2008?
Give a very brief answer. 0.61. What is the ratio of the Debt(% of exports of goods, services and primary income) in Solomon Islands in 2007 to that in 2008?
Provide a short and direct response. 1.11. What is the ratio of the Debt(% of exports of goods, services and primary income) of Tajikistan in 2007 to that in 2008?
Make the answer very short. 0.52. What is the ratio of the Debt(% of exports of goods, services and primary income) of Costa Rica in 2007 to that in 2009?
Provide a short and direct response. 0.76. What is the ratio of the Debt(% of exports of goods, services and primary income) of Solomon Islands in 2007 to that in 2009?
Offer a terse response. 1.42. What is the ratio of the Debt(% of exports of goods, services and primary income) in Tajikistan in 2007 to that in 2009?
Your response must be concise. 0.1. What is the ratio of the Debt(% of exports of goods, services and primary income) in Costa Rica in 2007 to that in 2010?
Offer a very short reply. 1.1. What is the ratio of the Debt(% of exports of goods, services and primary income) in Solomon Islands in 2007 to that in 2010?
Offer a very short reply. 0.96. What is the ratio of the Debt(% of exports of goods, services and primary income) in Tajikistan in 2007 to that in 2010?
Ensure brevity in your answer.  0.05. What is the ratio of the Debt(% of exports of goods, services and primary income) of Costa Rica in 2007 to that in 2011?
Keep it short and to the point. 0.77. What is the ratio of the Debt(% of exports of goods, services and primary income) of Solomon Islands in 2007 to that in 2011?
Give a very brief answer. 2.2. What is the ratio of the Debt(% of exports of goods, services and primary income) in Tajikistan in 2007 to that in 2011?
Provide a succinct answer. 0.08. What is the ratio of the Debt(% of exports of goods, services and primary income) of Costa Rica in 2007 to that in 2012?
Provide a succinct answer. 0.59. What is the ratio of the Debt(% of exports of goods, services and primary income) of Solomon Islands in 2007 to that in 2012?
Provide a succinct answer. 1.3. What is the ratio of the Debt(% of exports of goods, services and primary income) of Tajikistan in 2007 to that in 2012?
Provide a succinct answer. 0.15. What is the ratio of the Debt(% of exports of goods, services and primary income) of Costa Rica in 2008 to that in 2009?
Your answer should be very brief. 1.25. What is the ratio of the Debt(% of exports of goods, services and primary income) of Solomon Islands in 2008 to that in 2009?
Provide a succinct answer. 1.28. What is the ratio of the Debt(% of exports of goods, services and primary income) of Tajikistan in 2008 to that in 2009?
Your answer should be compact. 0.19. What is the ratio of the Debt(% of exports of goods, services and primary income) in Costa Rica in 2008 to that in 2010?
Provide a short and direct response. 1.81. What is the ratio of the Debt(% of exports of goods, services and primary income) of Solomon Islands in 2008 to that in 2010?
Ensure brevity in your answer.  0.87. What is the ratio of the Debt(% of exports of goods, services and primary income) of Tajikistan in 2008 to that in 2010?
Your answer should be very brief. 0.09. What is the ratio of the Debt(% of exports of goods, services and primary income) of Costa Rica in 2008 to that in 2011?
Provide a succinct answer. 1.25. What is the ratio of the Debt(% of exports of goods, services and primary income) in Solomon Islands in 2008 to that in 2011?
Make the answer very short. 1.99. What is the ratio of the Debt(% of exports of goods, services and primary income) of Tajikistan in 2008 to that in 2011?
Keep it short and to the point. 0.15. What is the ratio of the Debt(% of exports of goods, services and primary income) of Costa Rica in 2008 to that in 2012?
Your answer should be very brief. 0.96. What is the ratio of the Debt(% of exports of goods, services and primary income) of Solomon Islands in 2008 to that in 2012?
Your answer should be very brief. 1.18. What is the ratio of the Debt(% of exports of goods, services and primary income) of Tajikistan in 2008 to that in 2012?
Keep it short and to the point. 0.28. What is the ratio of the Debt(% of exports of goods, services and primary income) of Costa Rica in 2009 to that in 2010?
Offer a very short reply. 1.45. What is the ratio of the Debt(% of exports of goods, services and primary income) of Solomon Islands in 2009 to that in 2010?
Give a very brief answer. 0.68. What is the ratio of the Debt(% of exports of goods, services and primary income) of Tajikistan in 2009 to that in 2010?
Offer a terse response. 0.5. What is the ratio of the Debt(% of exports of goods, services and primary income) of Solomon Islands in 2009 to that in 2011?
Provide a short and direct response. 1.55. What is the ratio of the Debt(% of exports of goods, services and primary income) in Tajikistan in 2009 to that in 2011?
Your answer should be compact. 0.79. What is the ratio of the Debt(% of exports of goods, services and primary income) of Costa Rica in 2009 to that in 2012?
Give a very brief answer. 0.77. What is the ratio of the Debt(% of exports of goods, services and primary income) of Solomon Islands in 2009 to that in 2012?
Provide a short and direct response. 0.92. What is the ratio of the Debt(% of exports of goods, services and primary income) in Tajikistan in 2009 to that in 2012?
Provide a succinct answer. 1.49. What is the ratio of the Debt(% of exports of goods, services and primary income) of Costa Rica in 2010 to that in 2011?
Ensure brevity in your answer.  0.69. What is the ratio of the Debt(% of exports of goods, services and primary income) of Solomon Islands in 2010 to that in 2011?
Make the answer very short. 2.29. What is the ratio of the Debt(% of exports of goods, services and primary income) in Tajikistan in 2010 to that in 2011?
Offer a terse response. 1.58. What is the ratio of the Debt(% of exports of goods, services and primary income) of Costa Rica in 2010 to that in 2012?
Offer a terse response. 0.53. What is the ratio of the Debt(% of exports of goods, services and primary income) in Solomon Islands in 2010 to that in 2012?
Offer a terse response. 1.35. What is the ratio of the Debt(% of exports of goods, services and primary income) of Tajikistan in 2010 to that in 2012?
Provide a succinct answer. 2.99. What is the ratio of the Debt(% of exports of goods, services and primary income) of Costa Rica in 2011 to that in 2012?
Your response must be concise. 0.77. What is the ratio of the Debt(% of exports of goods, services and primary income) in Solomon Islands in 2011 to that in 2012?
Your answer should be very brief. 0.59. What is the ratio of the Debt(% of exports of goods, services and primary income) in Tajikistan in 2011 to that in 2012?
Make the answer very short. 1.9. What is the difference between the highest and the second highest Debt(% of exports of goods, services and primary income) in Costa Rica?
Ensure brevity in your answer.  0.58. What is the difference between the highest and the second highest Debt(% of exports of goods, services and primary income) of Solomon Islands?
Ensure brevity in your answer.  2.87. What is the difference between the highest and the second highest Debt(% of exports of goods, services and primary income) of Tajikistan?
Your response must be concise. 27.95. What is the difference between the highest and the lowest Debt(% of exports of goods, services and primary income) of Costa Rica?
Make the answer very short. 7.04. What is the difference between the highest and the lowest Debt(% of exports of goods, services and primary income) in Solomon Islands?
Keep it short and to the point. 6.61. What is the difference between the highest and the lowest Debt(% of exports of goods, services and primary income) in Tajikistan?
Your response must be concise. 72.57. 